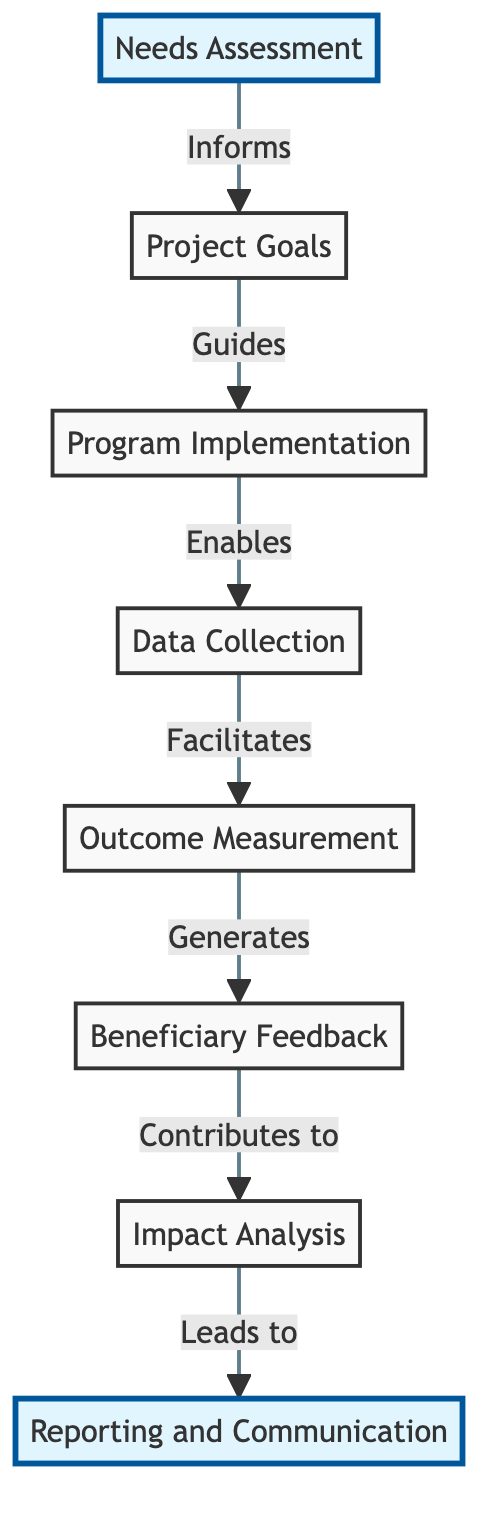What is the starting node in the diagram? The starting node in the diagram is "Needs Assessment," which is where the whole process begins. This can be determined by looking for the node that does not have any incoming edges but has outgoing connections to other nodes.
Answer: Needs Assessment How many nodes are present in the diagram? To find the number of nodes, we can simply count the unique nodes listed in the "nodes" section of the data. There are eight distinct nodes shown.
Answer: 8 What relationship exists between "Program Implementation" and "Data Collection"? The relationship is represented by a directed edge pointing from "Program Implementation" to "Data Collection," indicating that "Program Implementation" enables the data collection process. This is clear from the direction of the arrow connecting these two nodes.
Answer: Enables What node comes after "Outcome Measurement" in the flow? The node that comes after "Outcome Measurement" is "Beneficiary Feedback," which is directly connected as the next step in the flow according to the diagram’s structure.
Answer: Beneficiary Feedback Which node leads to "Reporting and Communication"? The node that leads to "Reporting and Communication" is "Impact Analysis." This relationship is defined by the directed edge that points from "Impact Analysis" directly to "Reporting and Communication."
Answer: Impact Analysis How many edges are present in the diagram? The edges can be counted by tallying all the connecting arrows in the "edges" portion of the data, representing the flow or relationships between nodes. There are seven edges in total.
Answer: 7 What is the role of "Beneficiary Feedback" in the process? "Beneficiary Feedback" contributes to "Impact Analysis," shown by the directed edge from "Beneficiary Feedback" towards "Impact Analysis," indicating the feedback is essential for analyzing the program's impact.
Answer: Contributes to Which node directly follows "Data Collection" in the diagram? The node that directly follows "Data Collection" is "Outcome Measurement," as indicated by the directed edge leading from "Data Collection" to "Outcome Measurement."
Answer: Outcome Measurement What type of feedback is used in the impact assessment process? The type of feedback used is "Beneficiary Feedback," which is collected and analyzed as part of the impact assessment process according to the node's position in the flow.
Answer: Beneficiary Feedback 